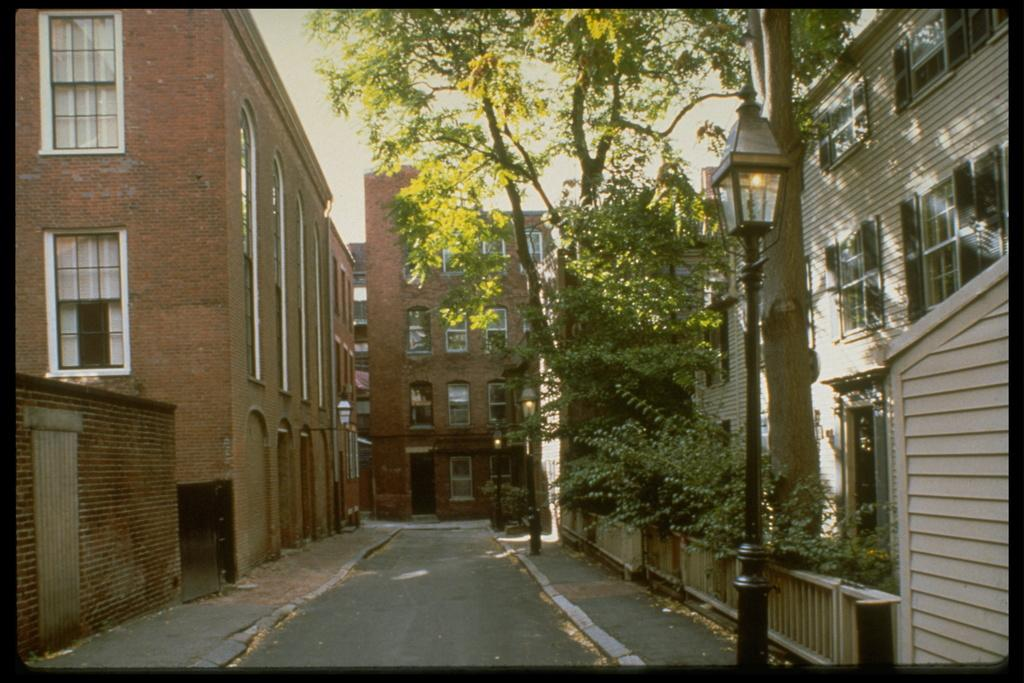What is the main feature of the image? There is a road in the image. What can be seen on both sides of the road? Buildings are present on both sides of the road. What other object is visible in the image? A pole is visible in the image. What type of vegetation is on the right side of the image? Plants and trees are present on the right side of the image. What type of bell can be heard ringing in the image? There is no bell present in the image, and therefore no sound can be heard. 